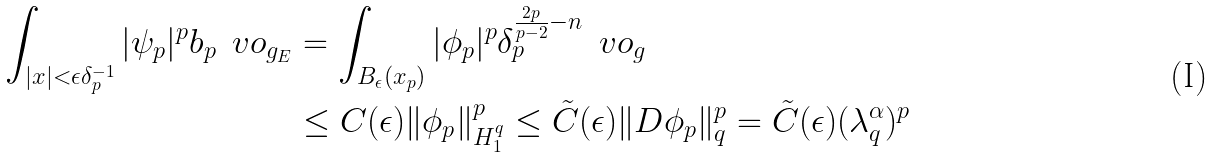<formula> <loc_0><loc_0><loc_500><loc_500>\int _ { | x | < \epsilon \delta ^ { - 1 } _ { p } } | \psi _ { p } | ^ { p } b _ { p } \, \ v o _ { g _ { E } } & = \int _ { B _ { \epsilon } ( x _ { p } ) } | \phi _ { p } | ^ { p } \delta _ { p } ^ { \frac { 2 p } { p - 2 } - n } \, \ v o _ { g } \\ & \leq C ( \epsilon ) \| \phi _ { p } \| ^ { p } _ { H _ { 1 } ^ { q } } \leq \tilde { C } ( \epsilon ) \| D \phi _ { p } \| ^ { p } _ { q } = \tilde { C } ( \epsilon ) ( \lambda ^ { \alpha } _ { q } ) ^ { p }</formula> 